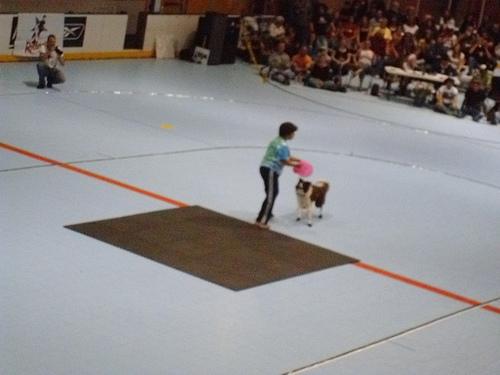What colors are the dog?
Write a very short answer. Brown and white. What color is the field?
Answer briefly. White. What type of court/field is in the picture?
Keep it brief. Hockey. 